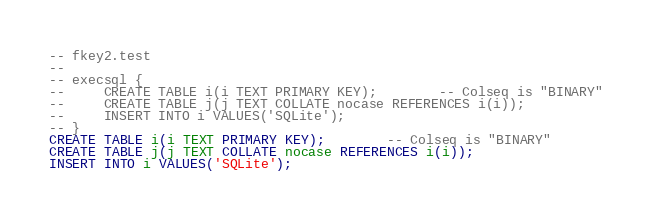<code> <loc_0><loc_0><loc_500><loc_500><_SQL_>-- fkey2.test
-- 
-- execsql {
--     CREATE TABLE i(i TEXT PRIMARY KEY);        -- Colseq is "BINARY"
--     CREATE TABLE j(j TEXT COLLATE nocase REFERENCES i(i));
--     INSERT INTO i VALUES('SQLite');
-- }
CREATE TABLE i(i TEXT PRIMARY KEY);        -- Colseq is "BINARY"
CREATE TABLE j(j TEXT COLLATE nocase REFERENCES i(i));
INSERT INTO i VALUES('SQLite');</code> 